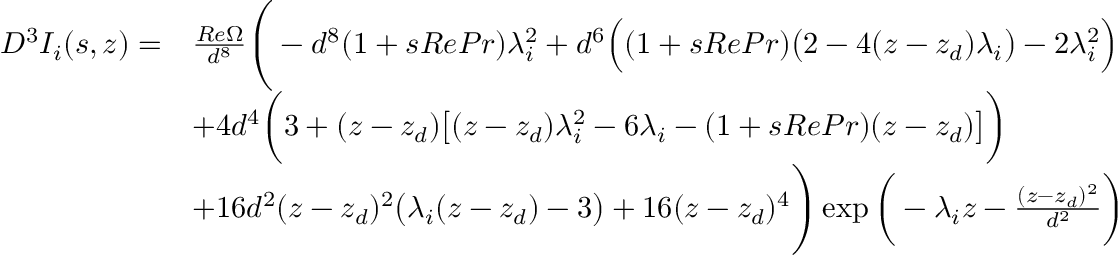Convert formula to latex. <formula><loc_0><loc_0><loc_500><loc_500>\begin{array} { r l } { D ^ { 3 } I _ { i } ( s , z ) = } & { \frac { R e \Omega } { d ^ { 8 } } \left ( - d ^ { 8 } ( 1 + s R e P r ) \lambda _ { i } ^ { 2 } + d ^ { 6 } \left ( ( 1 + s R e P r ) \left ( 2 - 4 ( z - z _ { d } ) \lambda _ { i } \right ) - 2 \lambda _ { i } ^ { 2 } \right ) } \\ & { + 4 d ^ { 4 } \left ( 3 + ( z - z _ { d } ) \left [ ( z - z _ { d } ) \lambda _ { i } ^ { 2 } - 6 \lambda _ { i } - ( 1 + s R e P r ) ( z - z _ { d } ) \right ] \right ) } \\ & { + 1 6 d ^ { 2 } ( z - z _ { d } ) ^ { 2 } \left ( \lambda _ { i } ( z - z _ { d } ) - 3 \right ) + 1 6 ( z - z _ { d } ) ^ { 4 } \right ) \exp \left ( - \lambda _ { i } z - \frac { ( z - z _ { d } ) ^ { 2 } } { d ^ { 2 } } \right ) } \end{array}</formula> 